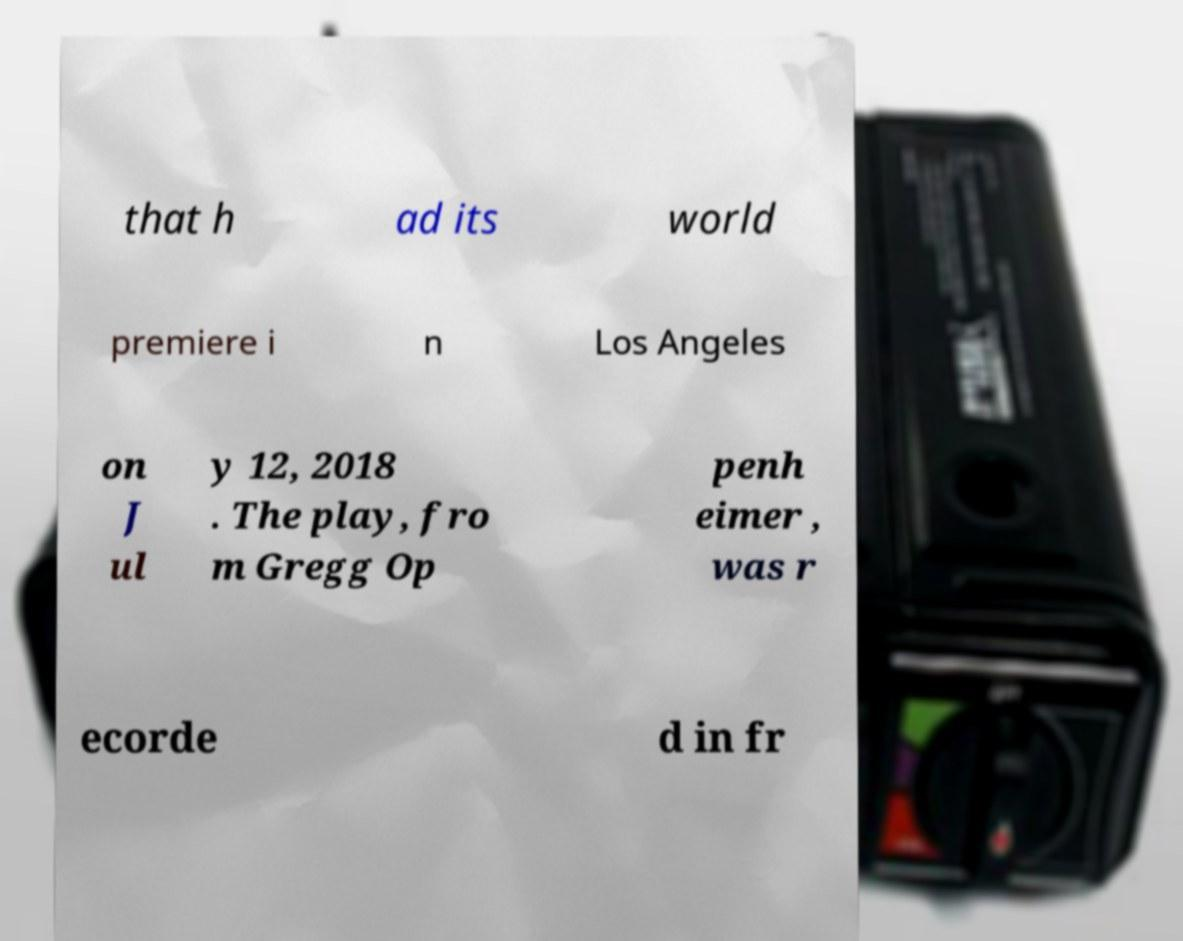Could you assist in decoding the text presented in this image and type it out clearly? that h ad its world premiere i n Los Angeles on J ul y 12, 2018 . The play, fro m Gregg Op penh eimer , was r ecorde d in fr 